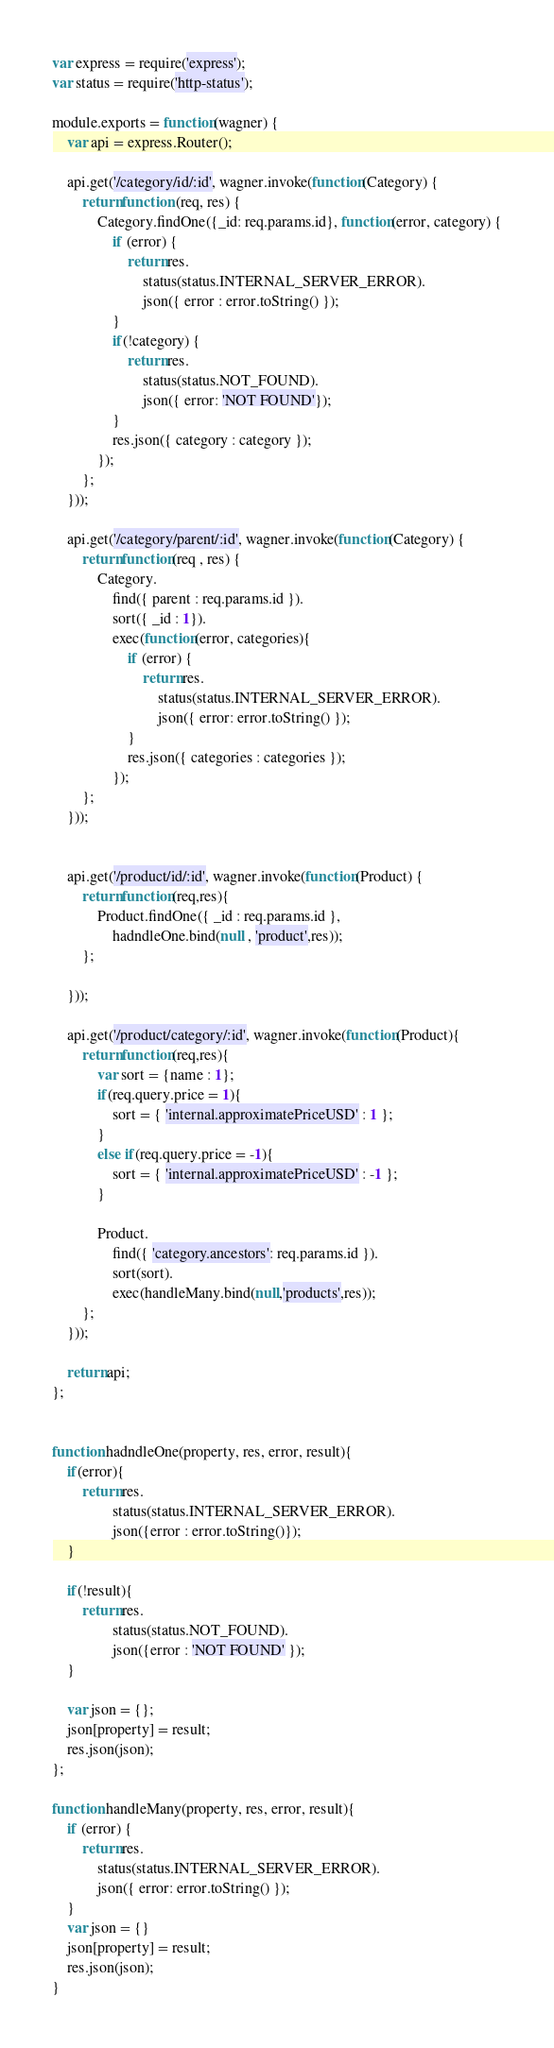Convert code to text. <code><loc_0><loc_0><loc_500><loc_500><_JavaScript_>var express = require('express');
var status = require('http-status');

module.exports = function(wagner) {
	var api = express.Router();

	api.get('/category/id/:id', wagner.invoke(function(Category) {
		return function (req, res) {
			Category.findOne({_id: req.params.id}, function(error, category) {
				if (error) {
					return res.
						status(status.INTERNAL_SERVER_ERROR).
						json({ error : error.toString() });
				}
				if(!category) {
					return res.
						status(status.NOT_FOUND).
						json({ error: 'NOT FOUND'});
				}
				res.json({ category : category });
			});
		};
	}));

	api.get('/category/parent/:id', wagner.invoke(function(Category) {
		return function(req , res) {
			Category.
				find({ parent : req.params.id }).
				sort({ _id : 1}).
				exec(function(error, categories){
					if (error) {
						return res.
							status(status.INTERNAL_SERVER_ERROR).
							json({ error: error.toString() });
					}
					res.json({ categories : categories });
				});
		};
	}));
	

	api.get('/product/id/:id', wagner.invoke(function(Product) {
		return function(req,res){
			Product.findOne({ _id : req.params.id },
				hadndleOne.bind(null , 'product',res));
		};

	}));

	api.get('/product/category/:id', wagner.invoke(function(Product){
		return function(req,res){
			var sort = {name : 1};
			if(req.query.price = 1){
				sort = { 'internal.approximatePriceUSD' : 1 };
			} 
			else if(req.query.price = -1){
				sort = { 'internal.approximatePriceUSD' : -1 };	
			}

			Product.
				find({ 'category.ancestors': req.params.id }).
				sort(sort).
				exec(handleMany.bind(null,'products',res));
		};
	}));

	return api;
};


function hadndleOne(property, res, error, result){
	if(error){
		return res.
				status(status.INTERNAL_SERVER_ERROR).
				json({error : error.toString()});
	}

	if(!result){
		return res.
				status(status.NOT_FOUND).
				json({error : 'NOT FOUND' });
	}

	var json = {};
	json[property] = result;
	res.json(json);
};

function handleMany(property, res, error, result){
	if (error) {
		return res.
			status(status.INTERNAL_SERVER_ERROR).
			json({ error: error.toString() });
	}
	var json = {}
	json[property] = result;
	res.json(json);	
}</code> 